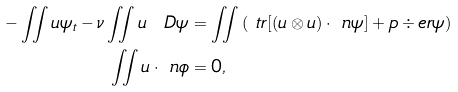Convert formula to latex. <formula><loc_0><loc_0><loc_500><loc_500>- \iint u \psi _ { t } - \nu \iint u \ D \psi & = \iint \left ( \ t r [ ( u \otimes u ) \cdot \ n \psi ] + p \div e r { \psi } \right ) \\ \iint u \cdot \ n \phi & = 0 ,</formula> 